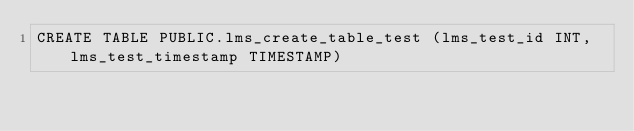<code> <loc_0><loc_0><loc_500><loc_500><_SQL_>CREATE TABLE PUBLIC.lms_create_table_test (lms_test_id INT, lms_test_timestamp TIMESTAMP)</code> 